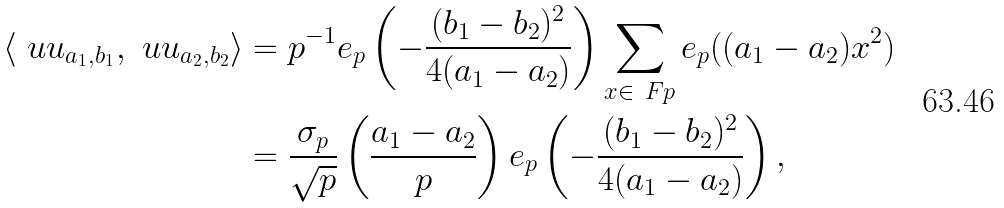<formula> <loc_0><loc_0><loc_500><loc_500>\langle \ u u _ { a _ { 1 } , b _ { 1 } } , \ u u _ { a _ { 2 } , b _ { 2 } } \rangle & = p ^ { - 1 } e _ { p } \left ( - \frac { ( b _ { 1 } - b _ { 2 } ) ^ { 2 } } { 4 ( a _ { 1 } - a _ { 2 } ) } \right ) \sum _ { x \in \ F p } e _ { p } ( ( a _ { 1 } - a _ { 2 } ) x ^ { 2 } ) \\ & = \frac { \sigma _ { p } } { \sqrt { p } } \left ( \frac { a _ { 1 } - a _ { 2 } } p \right ) e _ { p } \left ( - \frac { ( b _ { 1 } - b _ { 2 } ) ^ { 2 } } { 4 ( a _ { 1 } - a _ { 2 } ) } \right ) ,</formula> 